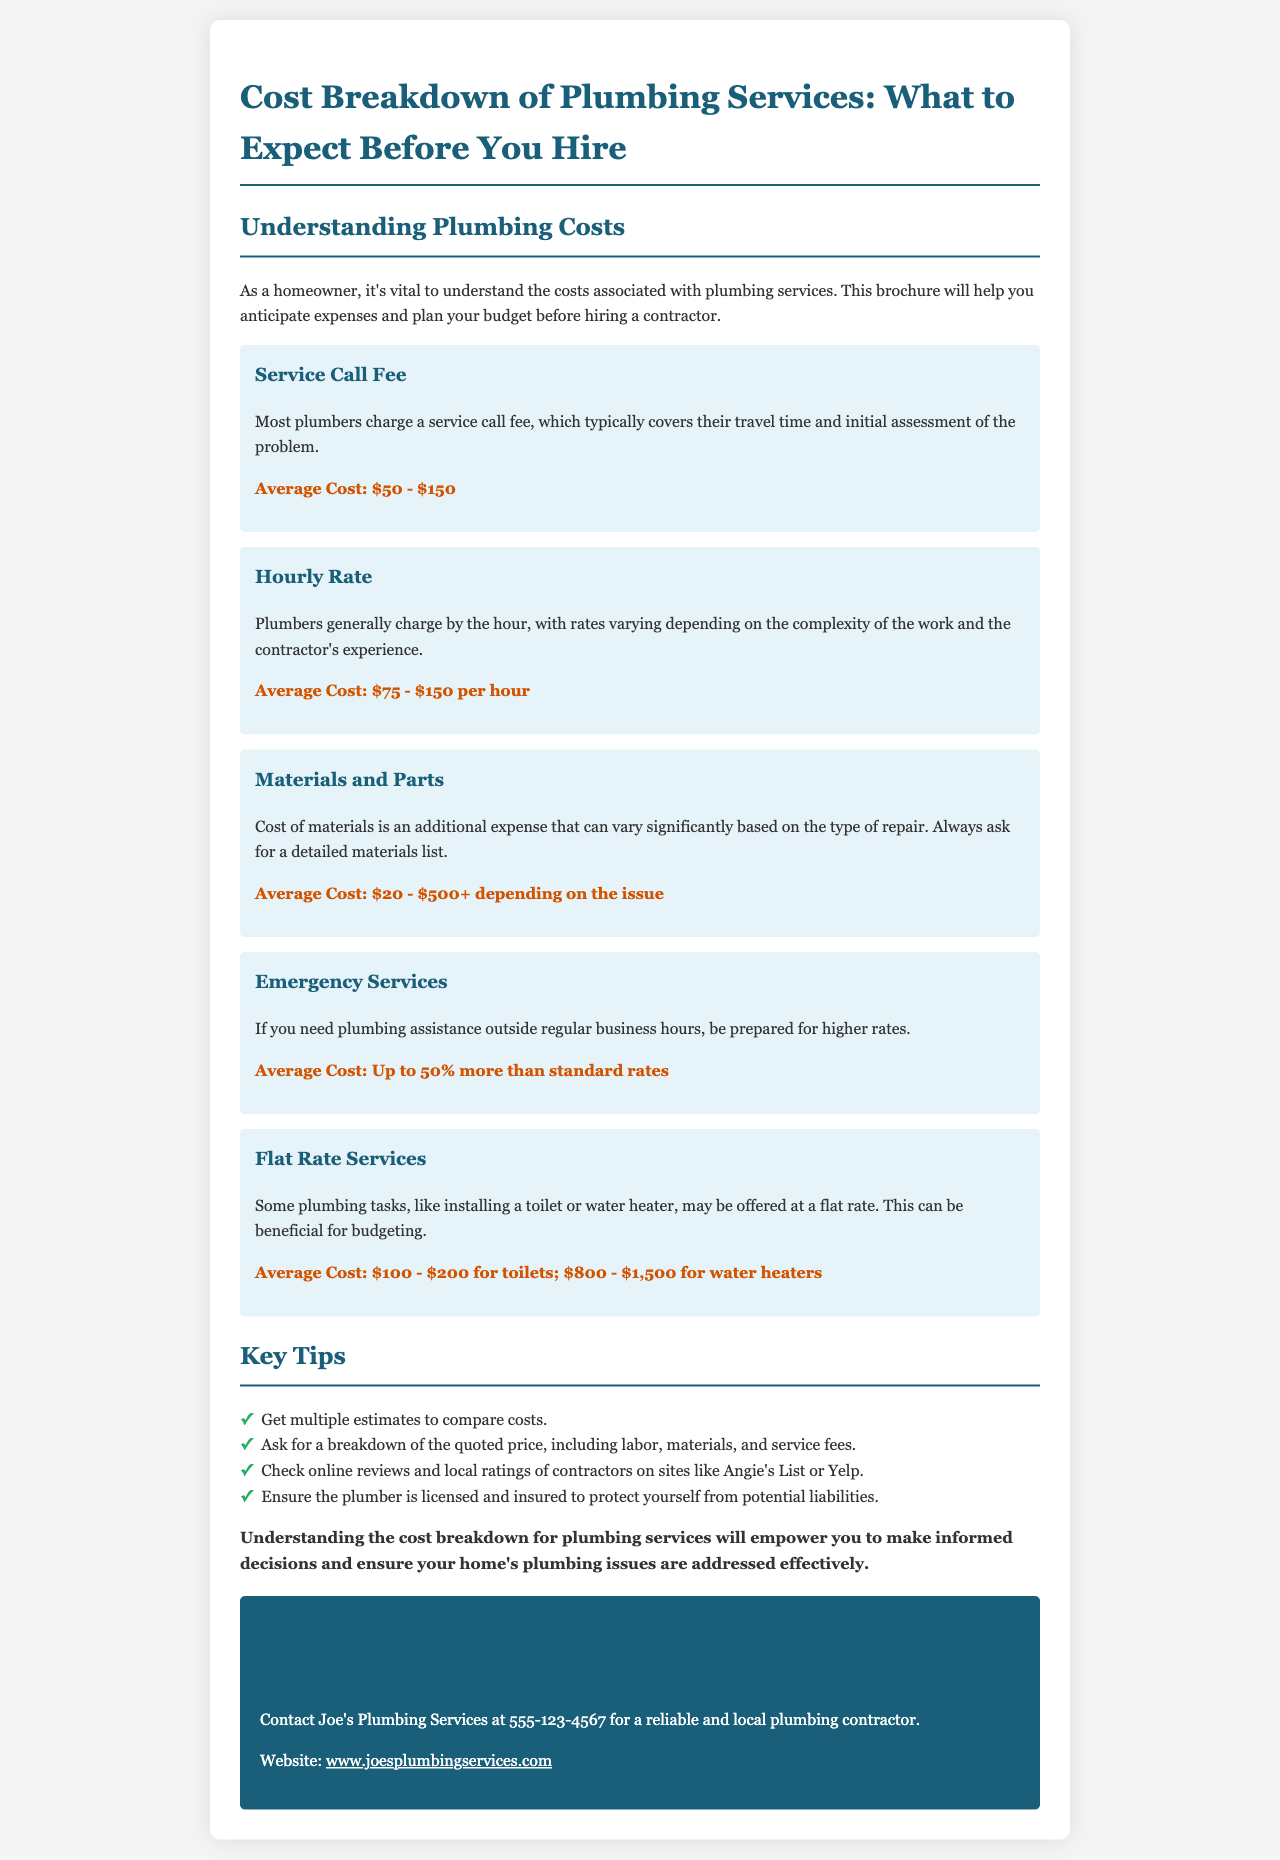What is the average cost for a service call fee? The average cost for a service call fee is provided in the document, which is between $50 and $150.
Answer: $50 - $150 What is the average hourly rate for plumbers? The document lists the average hourly rate for plumbers, which ranges from $75 to $150 per hour.
Answer: $75 - $150 per hour What percentage more do emergency services typically cost? The document states that emergency services may cost up to 50% more than standard rates.
Answer: Up to 50% What is the average cost range for installing a toilet? The document specifies the average cost for installing a toilet, which is between $100 and $200.
Answer: $100 - $200 Why is it important to get multiple estimates? The document advises getting multiple estimates to compare costs, which helps in making informed decisions.
Answer: To compare costs What should you ask for regarding materials? According to the document, you should ask for a detailed materials list to understand costs.
Answer: A detailed materials list Which document helps homeowners understand plumbing costs? The title of the document indicates its purpose for homeowners understanding costs related to plumbing.
Answer: Cost Breakdown of Plumbing Services What should you check about the plumbing contractor? The document advises checking if the plumber is licensed and insured to protect against potential liabilities.
Answer: Licensed and insured 